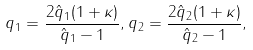Convert formula to latex. <formula><loc_0><loc_0><loc_500><loc_500>q _ { 1 } = \frac { 2 \hat { q } _ { 1 } ( 1 + \kappa ) } { \hat { q } _ { 1 } - 1 } , q _ { 2 } = \frac { 2 \hat { q } _ { 2 } ( 1 + \kappa ) } { \hat { q } _ { 2 } - 1 } ,</formula> 